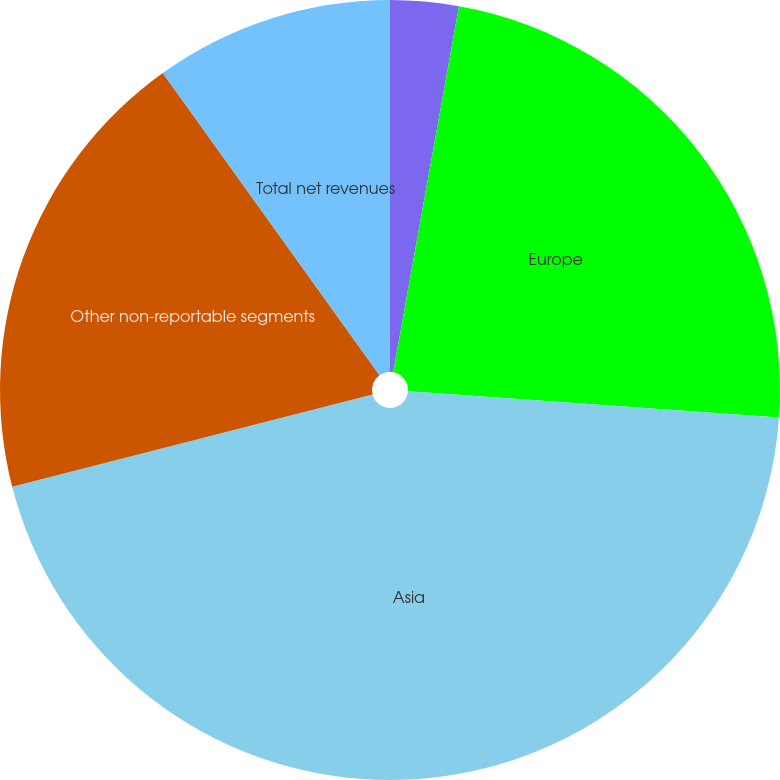<chart> <loc_0><loc_0><loc_500><loc_500><pie_chart><fcel>North America<fcel>Europe<fcel>Asia<fcel>Other non-reportable segments<fcel>Total net revenues<nl><fcel>2.83%<fcel>23.29%<fcel>44.89%<fcel>19.09%<fcel>9.9%<nl></chart> 